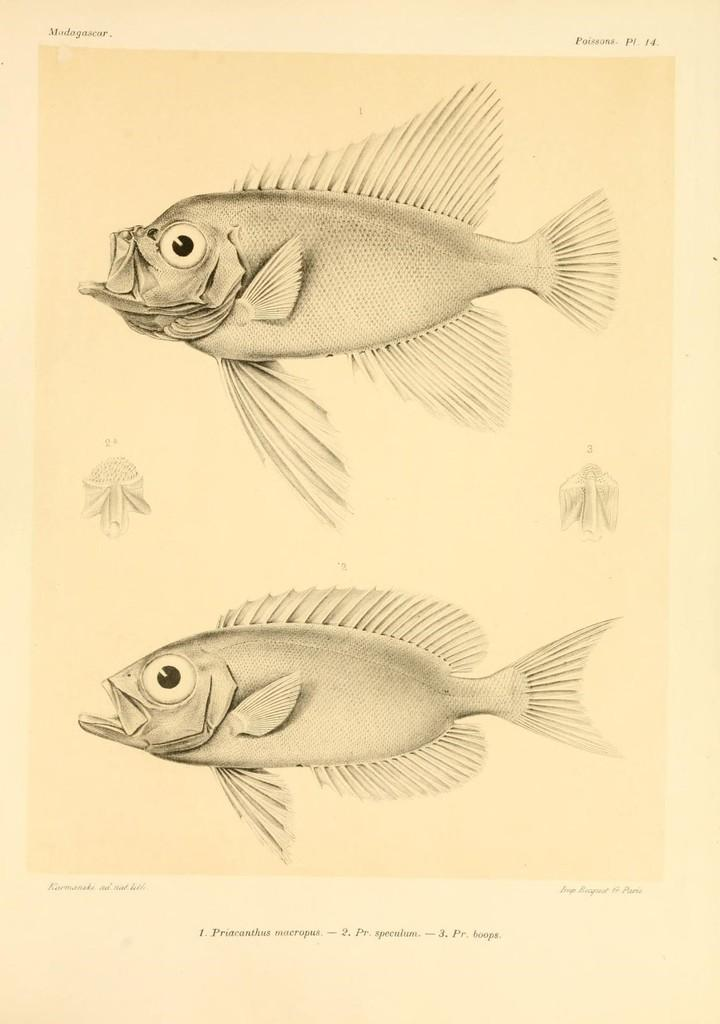What type of visual representation is the image? The image is a poster. What kind of animals are depicted on the poster? There are depictions of fish on the poster. Are there any words or phrases on the poster? Yes, there is text on the poster. How does the mask help the fish on the poster? There is no mask present on the poster, as it features depictions of fish and text. Can you tell me how many times the fish sneezed in the image? There is no indication of sneezing in the image, as it only features depictions of fish and text. 